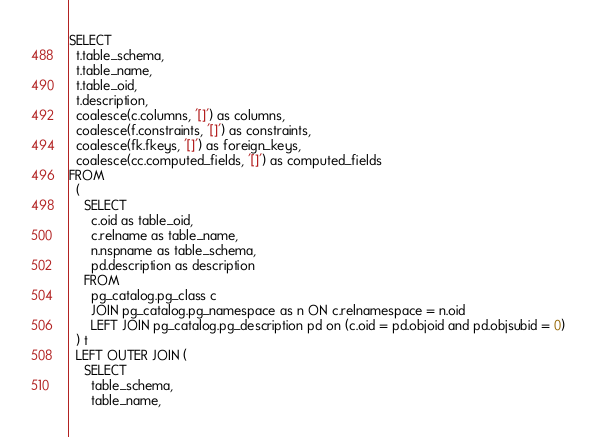Convert code to text. <code><loc_0><loc_0><loc_500><loc_500><_SQL_>SELECT
  t.table_schema,
  t.table_name,
  t.table_oid,
  t.description,
  coalesce(c.columns, '[]') as columns,
  coalesce(f.constraints, '[]') as constraints,
  coalesce(fk.fkeys, '[]') as foreign_keys,
  coalesce(cc.computed_fields, '[]') as computed_fields
FROM
  (
    SELECT
      c.oid as table_oid,
      c.relname as table_name,
      n.nspname as table_schema,
      pd.description as description
    FROM
      pg_catalog.pg_class c
      JOIN pg_catalog.pg_namespace as n ON c.relnamespace = n.oid
      LEFT JOIN pg_catalog.pg_description pd on (c.oid = pd.objoid and pd.objsubid = 0)
  ) t
  LEFT OUTER JOIN (
    SELECT
      table_schema,
      table_name,</code> 